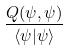<formula> <loc_0><loc_0><loc_500><loc_500>\frac { Q ( \psi , \psi ) } { \langle \psi | \psi \rangle }</formula> 